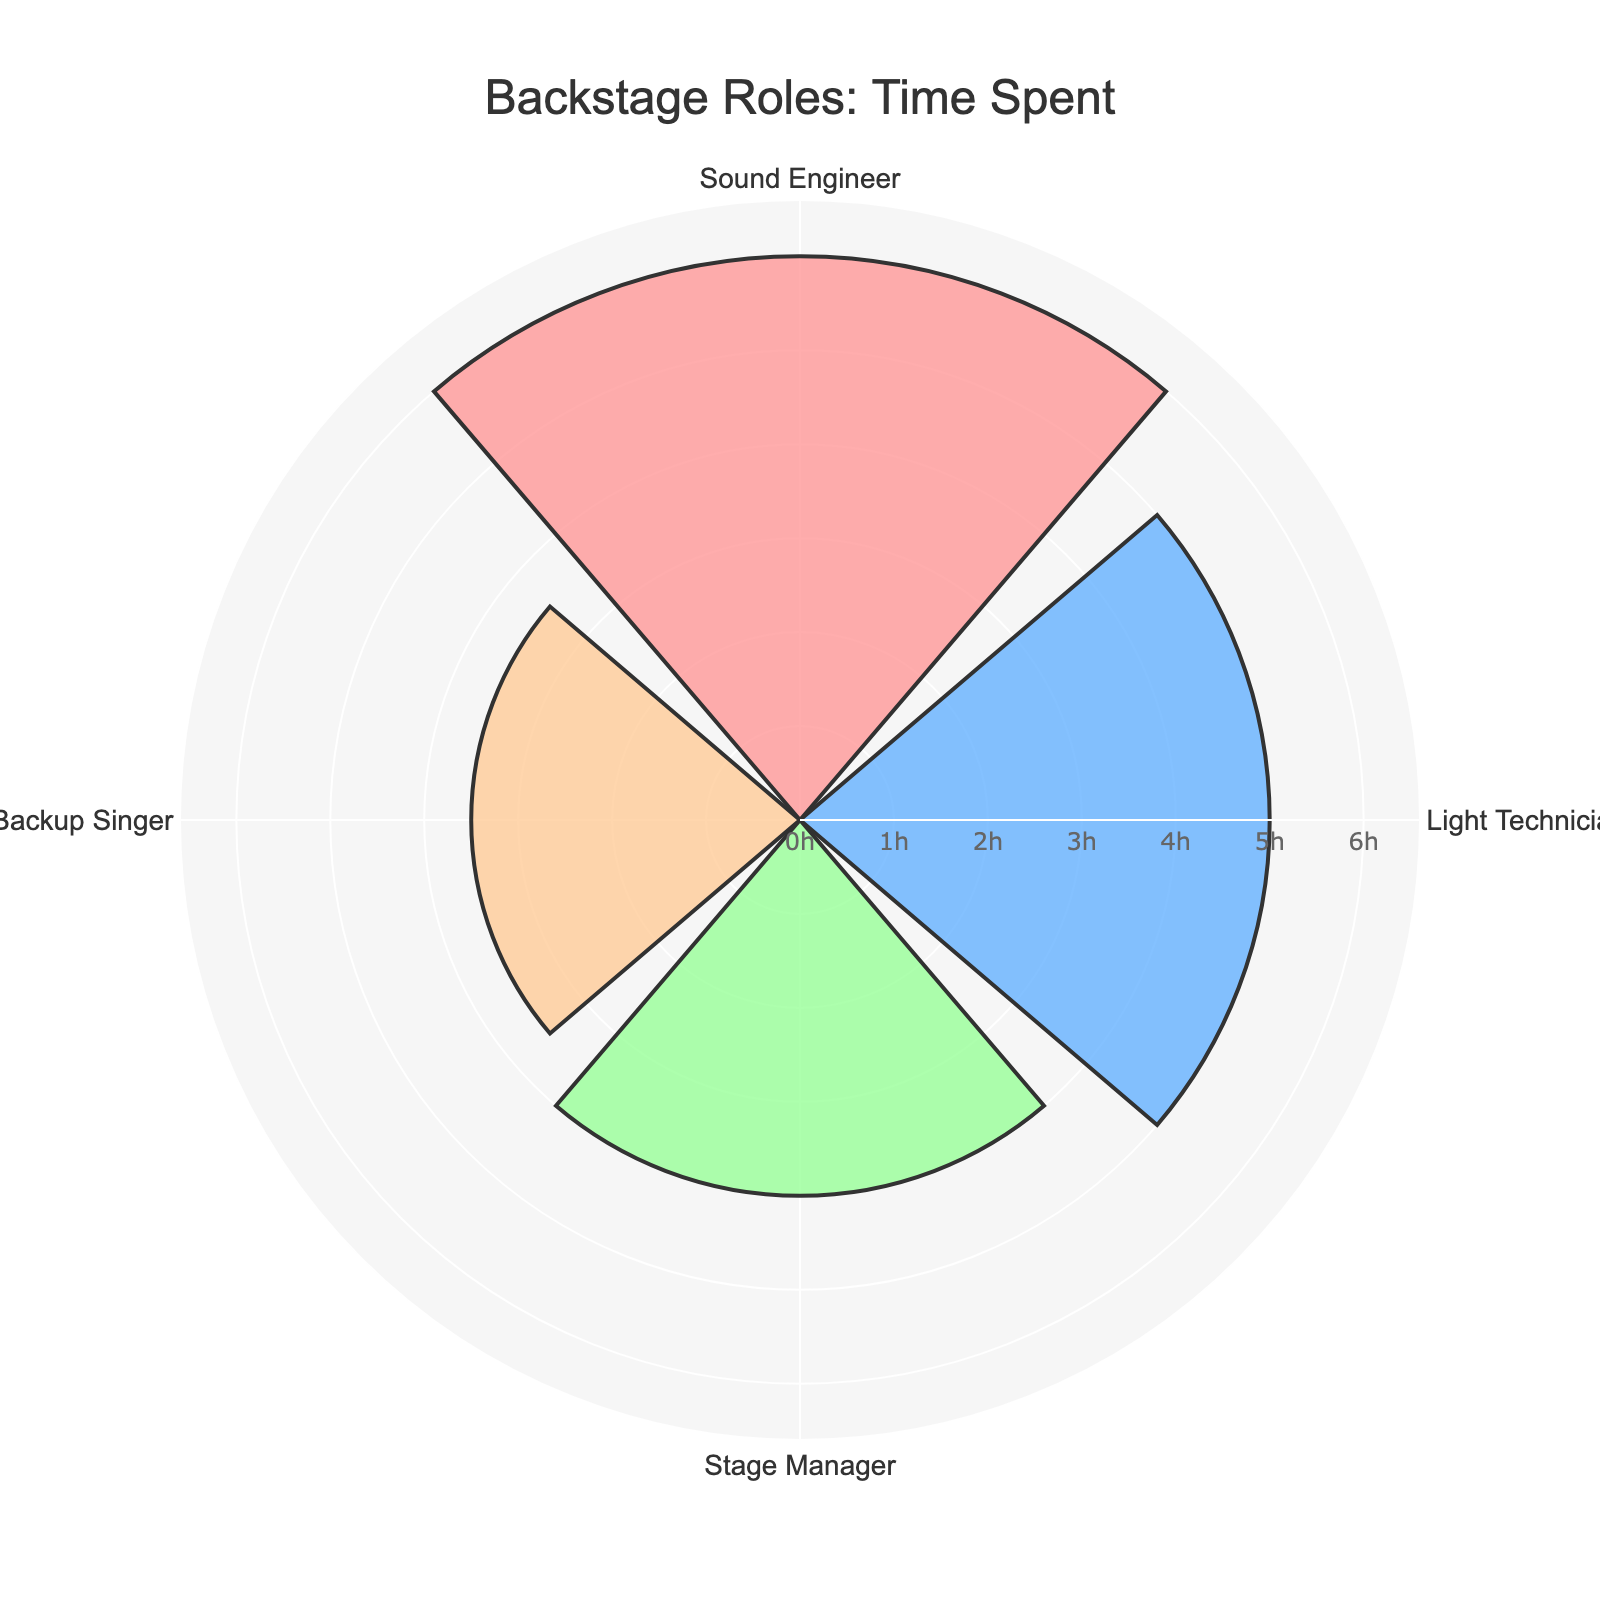What is the title of the figure? The title of the figure is displayed at the top center. It reads "Backstage Roles: Time Spent".
Answer: Backstage Roles: Time Spent How many roles are represented in the figure? Count the number of different roles listed around the circular chart. There are four roles.
Answer: Four What is the role with the light blue-colored bar? Look at the color of the bars; the light blue-colored bar corresponds to the Light Technician role.
Answer: Light Technician What is the maximum time spent on a single role? Observe the length of all the bars; the longest bar represents the Sound Engineer role, which is 6 hours.
Answer: 6 hours What is the total time spent on all roles combined? Sum the time spent on each role: 6 (Sound Engineer) + 5 (Light Technician) + 4 (Stage Manager) + 3.5 (Backup Singer) = 18.5 hours.
Answer: 18.5 hours What is the average time spent on each role? Find the total time spent on all roles and divide by the number of roles: 18.5 hours / 4 roles = 4.625 hours.
Answer: 4.625 hours By how many hours does the Sound Engineer's time exceed the backup singer's time? Subtract the time spent on Backup Singer from Sound Engineer: 6 hours (Sound Engineer) - 3.5 hours (Backup Singer) = 2.5 hours.
Answer: 2.5 hours What is the total time spent by the Stage Manager and Backup Singer combined? Add the time spent on Stage Manager to the time spent on Backup Singer: 4 hours + 3.5 hours = 7.5 hours.
Answer: 7.5 hours Which role has the least time spent? Identify the shortest bar in the figure; it corresponds to the Backup Singer role, with 3.5 hours.
Answer: Backup Singer Between the Light Technician and Stage Manager, who spends more time and by how much? Compare the time spent: Light Technician (5 hours) - Stage Manager (4 hours) = 1 hour. So, Light Technician spends 1 hour more.
Answer: Light Technician, 1 hour In the chart, which direction is used to align the role names? The role names are aligned in a clockwise direction around the chart.
Answer: Clockwise What is the background color of the chart's plotting area? The background of the plotting area, within the circular chart but not the entire figure, is light gray.
Answer: Light gray 